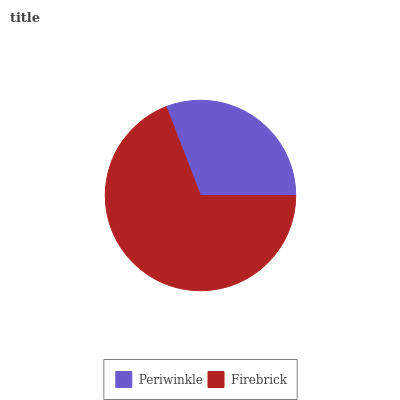Is Periwinkle the minimum?
Answer yes or no. Yes. Is Firebrick the maximum?
Answer yes or no. Yes. Is Firebrick the minimum?
Answer yes or no. No. Is Firebrick greater than Periwinkle?
Answer yes or no. Yes. Is Periwinkle less than Firebrick?
Answer yes or no. Yes. Is Periwinkle greater than Firebrick?
Answer yes or no. No. Is Firebrick less than Periwinkle?
Answer yes or no. No. Is Firebrick the high median?
Answer yes or no. Yes. Is Periwinkle the low median?
Answer yes or no. Yes. Is Periwinkle the high median?
Answer yes or no. No. Is Firebrick the low median?
Answer yes or no. No. 